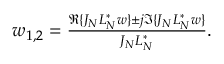Convert formula to latex. <formula><loc_0><loc_0><loc_500><loc_500>\begin{array} { r } { w _ { 1 , 2 } = \frac { \Re { \{ J _ { N } L _ { N } ^ { * } w \} } \pm j \Im { \{ J _ { N } L _ { N } ^ { * } w \} } } { J _ { N } L _ { N } ^ { * } } . } \end{array}</formula> 